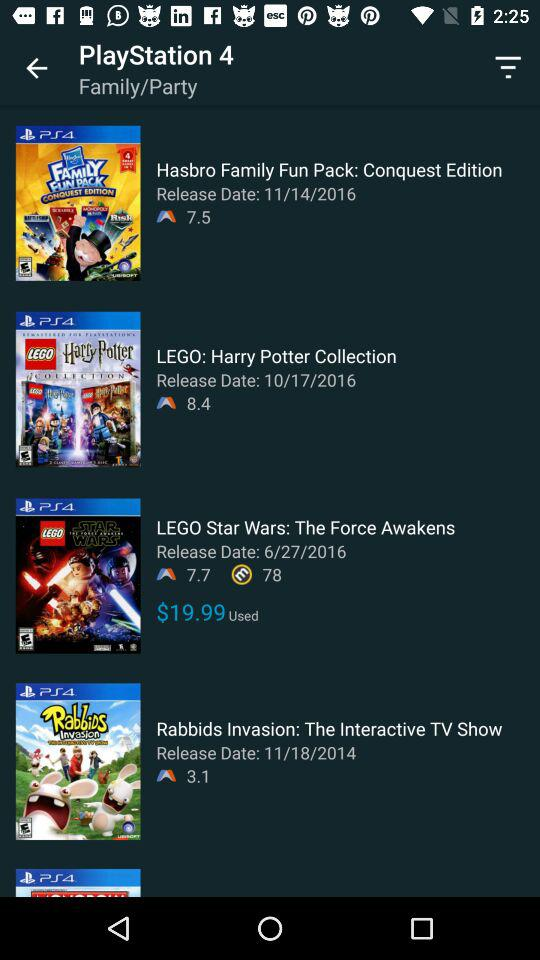What is the release date of the "LEGO: Harry Porter Collection"? The release date of the "LEGO: Harry Porter Collection" is October 17, 2016. 